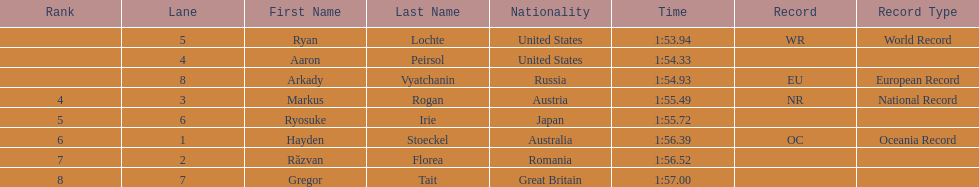Which country had the most medals in the competition? United States. 